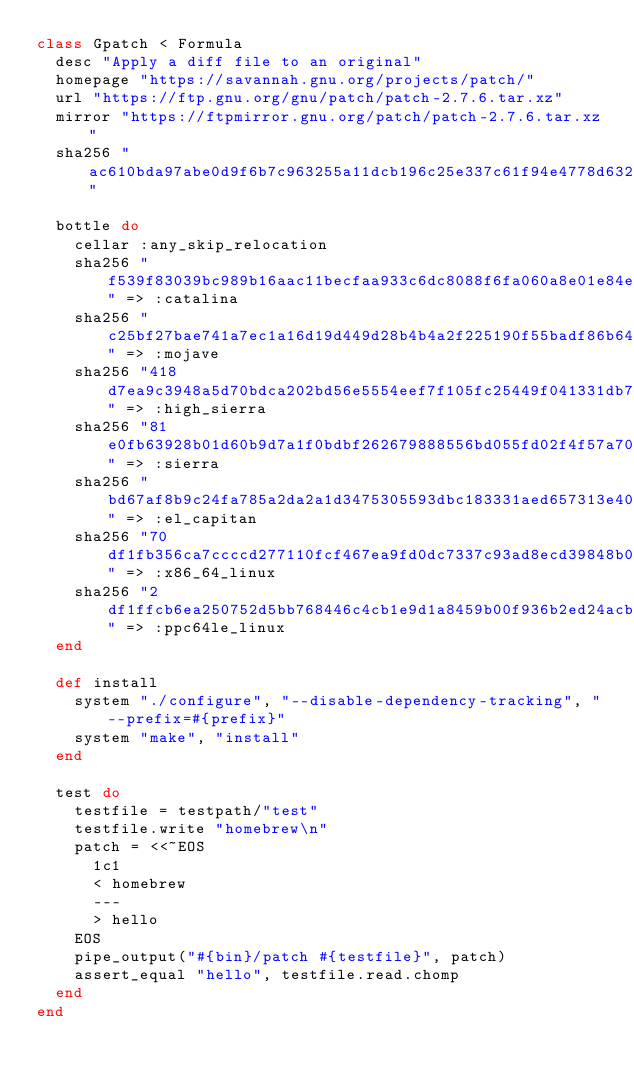Convert code to text. <code><loc_0><loc_0><loc_500><loc_500><_Ruby_>class Gpatch < Formula
  desc "Apply a diff file to an original"
  homepage "https://savannah.gnu.org/projects/patch/"
  url "https://ftp.gnu.org/gnu/patch/patch-2.7.6.tar.xz"
  mirror "https://ftpmirror.gnu.org/patch/patch-2.7.6.tar.xz"
  sha256 "ac610bda97abe0d9f6b7c963255a11dcb196c25e337c61f94e4778d632f1d8fd"

  bottle do
    cellar :any_skip_relocation
    sha256 "f539f83039bc989b16aac11becfaa933c6dc8088f6fa060a8e01e84ed0a61d77" => :catalina
    sha256 "c25bf27bae741a7ec1a16d19d449d28b4b4a2f225190f55badf86b64b0266f4d" => :mojave
    sha256 "418d7ea9c3948a5d70bdca202bd56e5554eef7f105fc25449f041331db7f4f96" => :high_sierra
    sha256 "81e0fb63928b01d60b9d7a1f0bdbf262679888556bd055fd02f4f57a70cb87ad" => :sierra
    sha256 "bd67af8b9c24fa785a2da2a1d3475305593dbc183331aed657313e4066de3259" => :el_capitan
    sha256 "70df1fb356ca7ccccd277110fcf467ea9fd0dc7337c93ad8ecd39848b081f95c" => :x86_64_linux
    sha256 "2df1ffcb6ea250752d5bb768446c4cb1e9d1a8459b00f936b2ed24acb360bc70" => :ppc64le_linux
  end

  def install
    system "./configure", "--disable-dependency-tracking", "--prefix=#{prefix}"
    system "make", "install"
  end

  test do
    testfile = testpath/"test"
    testfile.write "homebrew\n"
    patch = <<~EOS
      1c1
      < homebrew
      ---
      > hello
    EOS
    pipe_output("#{bin}/patch #{testfile}", patch)
    assert_equal "hello", testfile.read.chomp
  end
end
</code> 